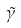<formula> <loc_0><loc_0><loc_500><loc_500>\tilde { \gamma }</formula> 